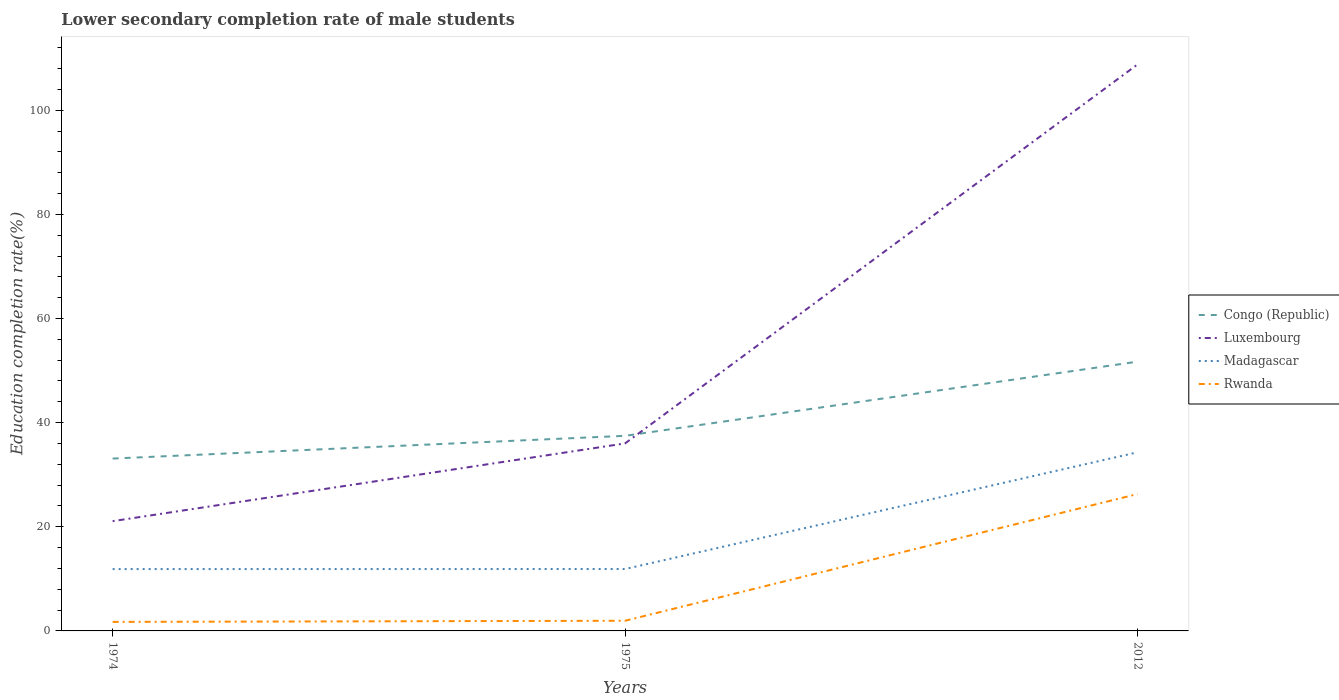Across all years, what is the maximum lower secondary completion rate of male students in Luxembourg?
Offer a terse response. 21.08. In which year was the lower secondary completion rate of male students in Rwanda maximum?
Make the answer very short. 1974. What is the total lower secondary completion rate of male students in Madagascar in the graph?
Your response must be concise. -0.01. What is the difference between the highest and the second highest lower secondary completion rate of male students in Congo (Republic)?
Your answer should be compact. 18.61. Is the lower secondary completion rate of male students in Luxembourg strictly greater than the lower secondary completion rate of male students in Congo (Republic) over the years?
Offer a terse response. No. What is the difference between two consecutive major ticks on the Y-axis?
Make the answer very short. 20. Are the values on the major ticks of Y-axis written in scientific E-notation?
Your answer should be very brief. No. Where does the legend appear in the graph?
Your answer should be very brief. Center right. How are the legend labels stacked?
Offer a very short reply. Vertical. What is the title of the graph?
Your answer should be very brief. Lower secondary completion rate of male students. What is the label or title of the X-axis?
Offer a very short reply. Years. What is the label or title of the Y-axis?
Keep it short and to the point. Education completion rate(%). What is the Education completion rate(%) in Congo (Republic) in 1974?
Keep it short and to the point. 33.1. What is the Education completion rate(%) in Luxembourg in 1974?
Give a very brief answer. 21.08. What is the Education completion rate(%) of Madagascar in 1974?
Provide a succinct answer. 11.88. What is the Education completion rate(%) of Rwanda in 1974?
Ensure brevity in your answer.  1.73. What is the Education completion rate(%) in Congo (Republic) in 1975?
Your answer should be very brief. 37.47. What is the Education completion rate(%) in Luxembourg in 1975?
Your answer should be very brief. 36.01. What is the Education completion rate(%) in Madagascar in 1975?
Give a very brief answer. 11.89. What is the Education completion rate(%) of Rwanda in 1975?
Your answer should be very brief. 1.95. What is the Education completion rate(%) in Congo (Republic) in 2012?
Make the answer very short. 51.72. What is the Education completion rate(%) in Luxembourg in 2012?
Ensure brevity in your answer.  108.79. What is the Education completion rate(%) in Madagascar in 2012?
Give a very brief answer. 34.3. What is the Education completion rate(%) of Rwanda in 2012?
Offer a terse response. 26.29. Across all years, what is the maximum Education completion rate(%) in Congo (Republic)?
Offer a very short reply. 51.72. Across all years, what is the maximum Education completion rate(%) of Luxembourg?
Offer a terse response. 108.79. Across all years, what is the maximum Education completion rate(%) of Madagascar?
Make the answer very short. 34.3. Across all years, what is the maximum Education completion rate(%) of Rwanda?
Offer a very short reply. 26.29. Across all years, what is the minimum Education completion rate(%) of Congo (Republic)?
Provide a short and direct response. 33.1. Across all years, what is the minimum Education completion rate(%) in Luxembourg?
Ensure brevity in your answer.  21.08. Across all years, what is the minimum Education completion rate(%) of Madagascar?
Provide a succinct answer. 11.88. Across all years, what is the minimum Education completion rate(%) in Rwanda?
Make the answer very short. 1.73. What is the total Education completion rate(%) of Congo (Republic) in the graph?
Keep it short and to the point. 122.29. What is the total Education completion rate(%) of Luxembourg in the graph?
Your answer should be very brief. 165.88. What is the total Education completion rate(%) of Madagascar in the graph?
Ensure brevity in your answer.  58.07. What is the total Education completion rate(%) of Rwanda in the graph?
Provide a succinct answer. 29.98. What is the difference between the Education completion rate(%) in Congo (Republic) in 1974 and that in 1975?
Your answer should be very brief. -4.37. What is the difference between the Education completion rate(%) of Luxembourg in 1974 and that in 1975?
Provide a short and direct response. -14.93. What is the difference between the Education completion rate(%) in Madagascar in 1974 and that in 1975?
Make the answer very short. -0.01. What is the difference between the Education completion rate(%) of Rwanda in 1974 and that in 1975?
Your answer should be compact. -0.22. What is the difference between the Education completion rate(%) of Congo (Republic) in 1974 and that in 2012?
Offer a very short reply. -18.61. What is the difference between the Education completion rate(%) of Luxembourg in 1974 and that in 2012?
Your answer should be compact. -87.71. What is the difference between the Education completion rate(%) in Madagascar in 1974 and that in 2012?
Keep it short and to the point. -22.43. What is the difference between the Education completion rate(%) in Rwanda in 1974 and that in 2012?
Provide a succinct answer. -24.56. What is the difference between the Education completion rate(%) of Congo (Republic) in 1975 and that in 2012?
Provide a succinct answer. -14.25. What is the difference between the Education completion rate(%) of Luxembourg in 1975 and that in 2012?
Give a very brief answer. -72.78. What is the difference between the Education completion rate(%) of Madagascar in 1975 and that in 2012?
Ensure brevity in your answer.  -22.42. What is the difference between the Education completion rate(%) in Rwanda in 1975 and that in 2012?
Give a very brief answer. -24.34. What is the difference between the Education completion rate(%) of Congo (Republic) in 1974 and the Education completion rate(%) of Luxembourg in 1975?
Ensure brevity in your answer.  -2.91. What is the difference between the Education completion rate(%) in Congo (Republic) in 1974 and the Education completion rate(%) in Madagascar in 1975?
Your response must be concise. 21.22. What is the difference between the Education completion rate(%) in Congo (Republic) in 1974 and the Education completion rate(%) in Rwanda in 1975?
Offer a very short reply. 31.15. What is the difference between the Education completion rate(%) in Luxembourg in 1974 and the Education completion rate(%) in Madagascar in 1975?
Your answer should be very brief. 9.19. What is the difference between the Education completion rate(%) of Luxembourg in 1974 and the Education completion rate(%) of Rwanda in 1975?
Make the answer very short. 19.13. What is the difference between the Education completion rate(%) in Madagascar in 1974 and the Education completion rate(%) in Rwanda in 1975?
Offer a very short reply. 9.92. What is the difference between the Education completion rate(%) in Congo (Republic) in 1974 and the Education completion rate(%) in Luxembourg in 2012?
Keep it short and to the point. -75.69. What is the difference between the Education completion rate(%) of Congo (Republic) in 1974 and the Education completion rate(%) of Madagascar in 2012?
Ensure brevity in your answer.  -1.2. What is the difference between the Education completion rate(%) in Congo (Republic) in 1974 and the Education completion rate(%) in Rwanda in 2012?
Keep it short and to the point. 6.81. What is the difference between the Education completion rate(%) of Luxembourg in 1974 and the Education completion rate(%) of Madagascar in 2012?
Your answer should be very brief. -13.22. What is the difference between the Education completion rate(%) in Luxembourg in 1974 and the Education completion rate(%) in Rwanda in 2012?
Keep it short and to the point. -5.21. What is the difference between the Education completion rate(%) of Madagascar in 1974 and the Education completion rate(%) of Rwanda in 2012?
Provide a succinct answer. -14.42. What is the difference between the Education completion rate(%) in Congo (Republic) in 1975 and the Education completion rate(%) in Luxembourg in 2012?
Your answer should be compact. -71.32. What is the difference between the Education completion rate(%) in Congo (Republic) in 1975 and the Education completion rate(%) in Madagascar in 2012?
Offer a very short reply. 3.17. What is the difference between the Education completion rate(%) of Congo (Republic) in 1975 and the Education completion rate(%) of Rwanda in 2012?
Make the answer very short. 11.18. What is the difference between the Education completion rate(%) in Luxembourg in 1975 and the Education completion rate(%) in Madagascar in 2012?
Make the answer very short. 1.71. What is the difference between the Education completion rate(%) in Luxembourg in 1975 and the Education completion rate(%) in Rwanda in 2012?
Give a very brief answer. 9.72. What is the difference between the Education completion rate(%) of Madagascar in 1975 and the Education completion rate(%) of Rwanda in 2012?
Offer a very short reply. -14.4. What is the average Education completion rate(%) in Congo (Republic) per year?
Make the answer very short. 40.76. What is the average Education completion rate(%) in Luxembourg per year?
Provide a succinct answer. 55.29. What is the average Education completion rate(%) of Madagascar per year?
Keep it short and to the point. 19.36. What is the average Education completion rate(%) in Rwanda per year?
Give a very brief answer. 9.99. In the year 1974, what is the difference between the Education completion rate(%) of Congo (Republic) and Education completion rate(%) of Luxembourg?
Offer a very short reply. 12.02. In the year 1974, what is the difference between the Education completion rate(%) of Congo (Republic) and Education completion rate(%) of Madagascar?
Offer a very short reply. 21.23. In the year 1974, what is the difference between the Education completion rate(%) in Congo (Republic) and Education completion rate(%) in Rwanda?
Give a very brief answer. 31.37. In the year 1974, what is the difference between the Education completion rate(%) in Luxembourg and Education completion rate(%) in Madagascar?
Offer a very short reply. 9.2. In the year 1974, what is the difference between the Education completion rate(%) of Luxembourg and Education completion rate(%) of Rwanda?
Offer a very short reply. 19.35. In the year 1974, what is the difference between the Education completion rate(%) of Madagascar and Education completion rate(%) of Rwanda?
Offer a very short reply. 10.14. In the year 1975, what is the difference between the Education completion rate(%) of Congo (Republic) and Education completion rate(%) of Luxembourg?
Offer a very short reply. 1.46. In the year 1975, what is the difference between the Education completion rate(%) in Congo (Republic) and Education completion rate(%) in Madagascar?
Keep it short and to the point. 25.58. In the year 1975, what is the difference between the Education completion rate(%) in Congo (Republic) and Education completion rate(%) in Rwanda?
Offer a very short reply. 35.52. In the year 1975, what is the difference between the Education completion rate(%) of Luxembourg and Education completion rate(%) of Madagascar?
Your answer should be compact. 24.12. In the year 1975, what is the difference between the Education completion rate(%) of Luxembourg and Education completion rate(%) of Rwanda?
Make the answer very short. 34.06. In the year 1975, what is the difference between the Education completion rate(%) of Madagascar and Education completion rate(%) of Rwanda?
Keep it short and to the point. 9.93. In the year 2012, what is the difference between the Education completion rate(%) of Congo (Republic) and Education completion rate(%) of Luxembourg?
Provide a succinct answer. -57.08. In the year 2012, what is the difference between the Education completion rate(%) in Congo (Republic) and Education completion rate(%) in Madagascar?
Keep it short and to the point. 17.41. In the year 2012, what is the difference between the Education completion rate(%) in Congo (Republic) and Education completion rate(%) in Rwanda?
Offer a terse response. 25.42. In the year 2012, what is the difference between the Education completion rate(%) in Luxembourg and Education completion rate(%) in Madagascar?
Give a very brief answer. 74.49. In the year 2012, what is the difference between the Education completion rate(%) in Luxembourg and Education completion rate(%) in Rwanda?
Make the answer very short. 82.5. In the year 2012, what is the difference between the Education completion rate(%) in Madagascar and Education completion rate(%) in Rwanda?
Give a very brief answer. 8.01. What is the ratio of the Education completion rate(%) in Congo (Republic) in 1974 to that in 1975?
Ensure brevity in your answer.  0.88. What is the ratio of the Education completion rate(%) in Luxembourg in 1974 to that in 1975?
Offer a terse response. 0.59. What is the ratio of the Education completion rate(%) in Rwanda in 1974 to that in 1975?
Your answer should be compact. 0.89. What is the ratio of the Education completion rate(%) in Congo (Republic) in 1974 to that in 2012?
Your answer should be compact. 0.64. What is the ratio of the Education completion rate(%) of Luxembourg in 1974 to that in 2012?
Make the answer very short. 0.19. What is the ratio of the Education completion rate(%) of Madagascar in 1974 to that in 2012?
Your answer should be compact. 0.35. What is the ratio of the Education completion rate(%) of Rwanda in 1974 to that in 2012?
Provide a succinct answer. 0.07. What is the ratio of the Education completion rate(%) of Congo (Republic) in 1975 to that in 2012?
Your answer should be very brief. 0.72. What is the ratio of the Education completion rate(%) in Luxembourg in 1975 to that in 2012?
Keep it short and to the point. 0.33. What is the ratio of the Education completion rate(%) of Madagascar in 1975 to that in 2012?
Offer a very short reply. 0.35. What is the ratio of the Education completion rate(%) in Rwanda in 1975 to that in 2012?
Provide a succinct answer. 0.07. What is the difference between the highest and the second highest Education completion rate(%) of Congo (Republic)?
Make the answer very short. 14.25. What is the difference between the highest and the second highest Education completion rate(%) in Luxembourg?
Provide a succinct answer. 72.78. What is the difference between the highest and the second highest Education completion rate(%) of Madagascar?
Your answer should be compact. 22.42. What is the difference between the highest and the second highest Education completion rate(%) in Rwanda?
Offer a terse response. 24.34. What is the difference between the highest and the lowest Education completion rate(%) of Congo (Republic)?
Ensure brevity in your answer.  18.61. What is the difference between the highest and the lowest Education completion rate(%) in Luxembourg?
Your response must be concise. 87.71. What is the difference between the highest and the lowest Education completion rate(%) in Madagascar?
Offer a terse response. 22.43. What is the difference between the highest and the lowest Education completion rate(%) of Rwanda?
Provide a short and direct response. 24.56. 